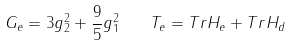Convert formula to latex. <formula><loc_0><loc_0><loc_500><loc_500>G _ { e } = 3 g _ { 2 } ^ { 2 } + { \frac { 9 } { 5 } } g _ { 1 } ^ { 2 } \quad T _ { e } = T r H _ { e } + T r H _ { d }</formula> 